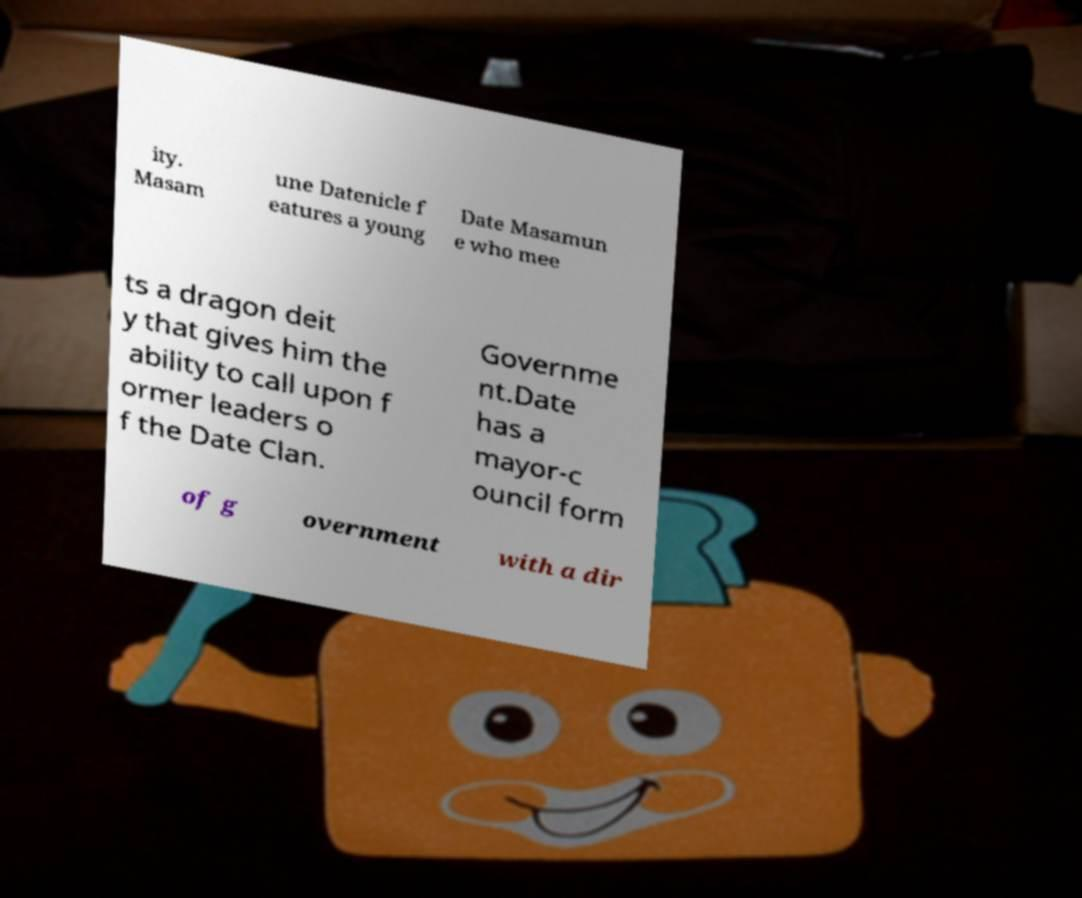There's text embedded in this image that I need extracted. Can you transcribe it verbatim? ity. Masam une Datenicle f eatures a young Date Masamun e who mee ts a dragon deit y that gives him the ability to call upon f ormer leaders o f the Date Clan. Governme nt.Date has a mayor-c ouncil form of g overnment with a dir 